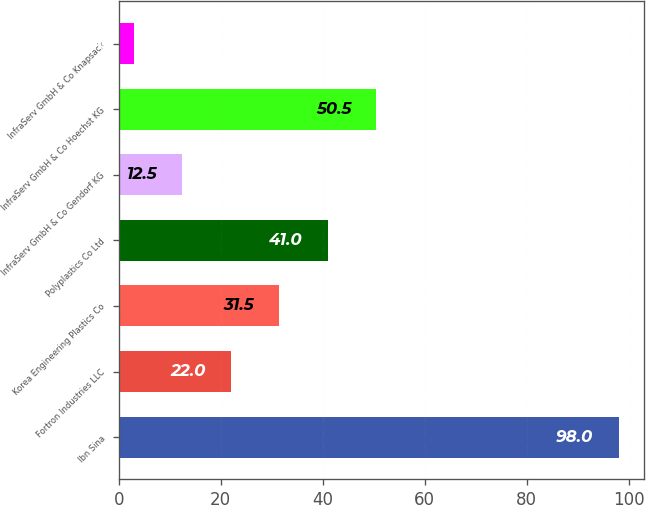Convert chart to OTSL. <chart><loc_0><loc_0><loc_500><loc_500><bar_chart><fcel>Ibn Sina<fcel>Fortron Industries LLC<fcel>Korea Engineering Plastics Co<fcel>Polyplastics Co Ltd<fcel>InfraServ GmbH & Co Gendorf KG<fcel>InfraServ GmbH & Co Hoechst KG<fcel>InfraServ GmbH & Co Knapsack<nl><fcel>98<fcel>22<fcel>31.5<fcel>41<fcel>12.5<fcel>50.5<fcel>3<nl></chart> 